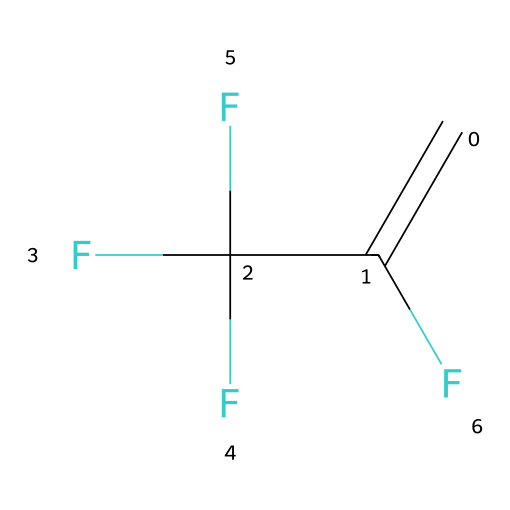What is the molecular formula of R-1234yf? The SMILES representation indicates the molecular structure, which consists of three carbon atoms, two hydrogen atoms, and four fluorine atoms, thus the molecular formula is C3H2F4.
Answer: C3H2F4 How many carbon atoms are present in R-1234yf? By examining the SMILES notation, there are three carbon atoms represented in the structure.
Answer: 3 What type of refrigerant is R-1234yf classified as? R-1234yf is categorized as a hydrofluorocarbon (HFC), which can be inferred by its composition of hydrogen, carbon, and fluorine.
Answer: hydrofluorocarbon What is the significance of the double bond in R-1234yf? The presence of a double bond (C=C) in the SMILES structure indicates that R-1234yf is an unsaturated compound, which typically affects its reactivity and thermodynamic properties important for refrigerant applications.
Answer: unsaturated How many fluorine atoms are in R-1234yf? The SMILES representation shows four fluorine atoms (F) attached to the carbon skeleton of the molecule.
Answer: 4 What characteristic of R-1234yf makes it more environmentally friendly than older refrigerants? R-1234yf has a significantly lower global warming potential than older refrigerants such as R-134a, primarily due to its lower fluoride content, as indicated by its structural composition.
Answer: lower global warming potential What is the impact of the F atoms on R-1234yf's properties? The fluorine atoms in R-1234yf influence its stability, low flammability, and effective heat transfer properties, which are essential characteristics for a refrigerant used in high-end vehicles.
Answer: stability and low flammability 